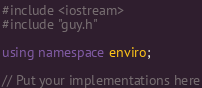<code> <loc_0><loc_0><loc_500><loc_500><_C++_>#include <iostream>
#include "guy.h"

using namespace enviro;

// Put your implementations here</code> 